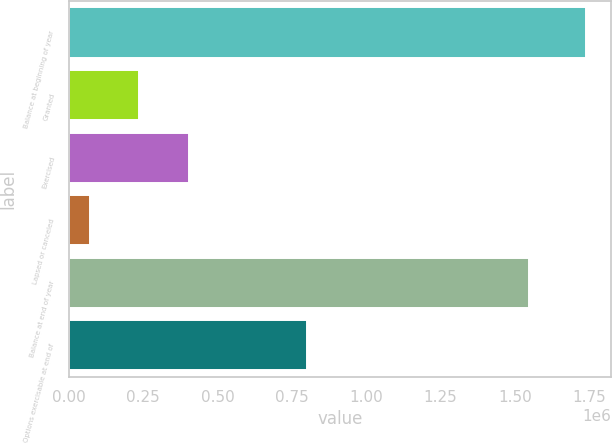Convert chart to OTSL. <chart><loc_0><loc_0><loc_500><loc_500><bar_chart><fcel>Balance at beginning of year<fcel>Granted<fcel>Exercised<fcel>Lapsed or canceled<fcel>Balance at end of year<fcel>Options exercisable at end of<nl><fcel>1.73721e+06<fcel>236992<fcel>403683<fcel>70301<fcel>1.54872e+06<fcel>800902<nl></chart> 